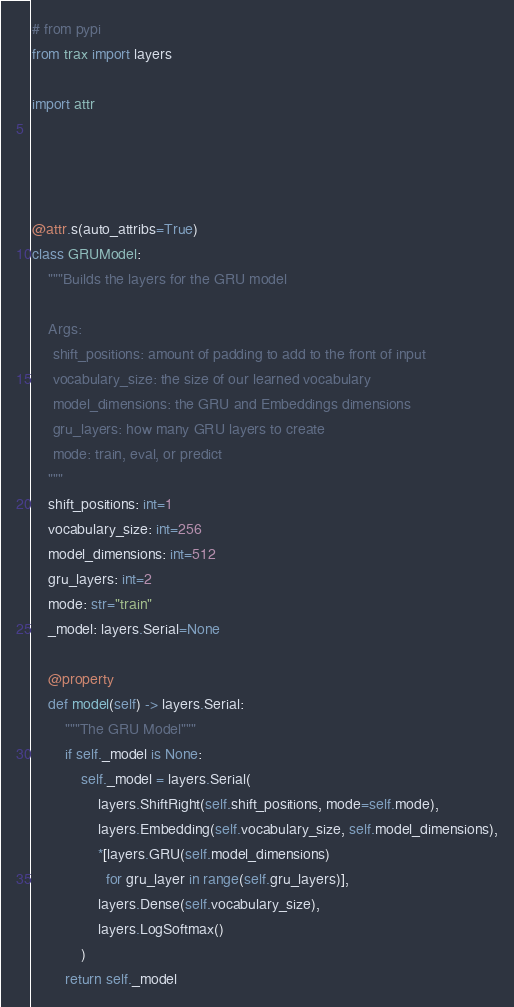Convert code to text. <code><loc_0><loc_0><loc_500><loc_500><_Python_># from pypi
from trax import layers

import attr




@attr.s(auto_attribs=True)
class GRUModel:
    """Builds the layers for the GRU model

    Args:
     shift_positions: amount of padding to add to the front of input
     vocabulary_size: the size of our learned vocabulary
     model_dimensions: the GRU and Embeddings dimensions
     gru_layers: how many GRU layers to create
     mode: train, eval, or predict
    """
    shift_positions: int=1
    vocabulary_size: int=256
    model_dimensions: int=512
    gru_layers: int=2
    mode: str="train"
    _model: layers.Serial=None

    @property
    def model(self) -> layers.Serial:
        """The GRU Model"""
        if self._model is None:
            self._model = layers.Serial(
                layers.ShiftRight(self.shift_positions, mode=self.mode),
                layers.Embedding(self.vocabulary_size, self.model_dimensions),
                *[layers.GRU(self.model_dimensions)
                  for gru_layer in range(self.gru_layers)],
                layers.Dense(self.vocabulary_size),
                layers.LogSoftmax()
            )
        return self._model
</code> 